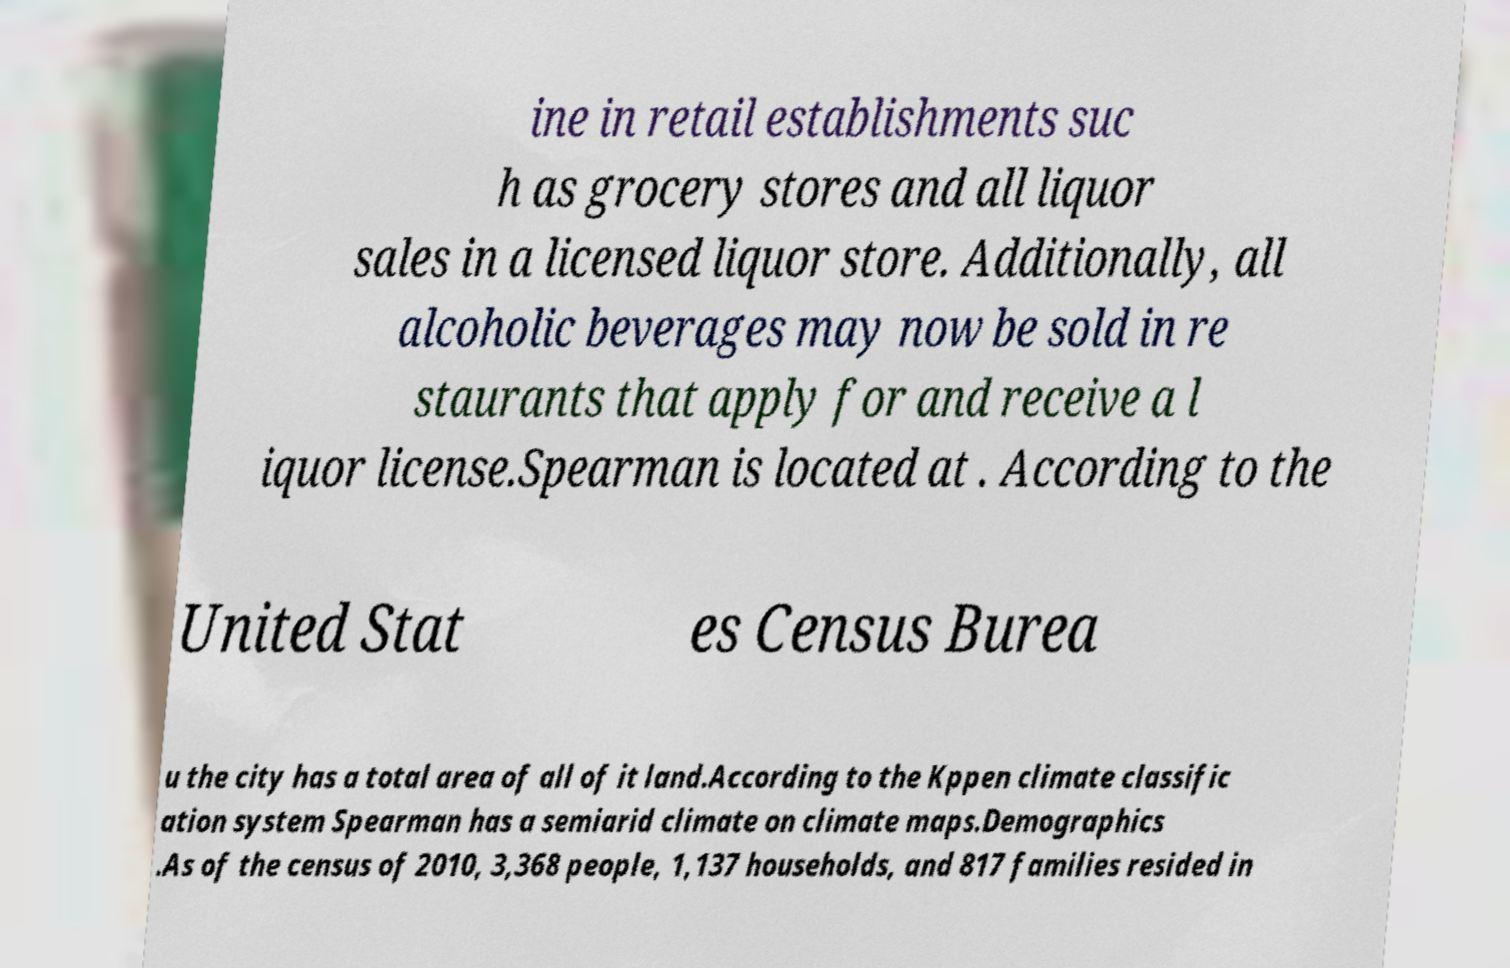Can you read and provide the text displayed in the image?This photo seems to have some interesting text. Can you extract and type it out for me? ine in retail establishments suc h as grocery stores and all liquor sales in a licensed liquor store. Additionally, all alcoholic beverages may now be sold in re staurants that apply for and receive a l iquor license.Spearman is located at . According to the United Stat es Census Burea u the city has a total area of all of it land.According to the Kppen climate classific ation system Spearman has a semiarid climate on climate maps.Demographics .As of the census of 2010, 3,368 people, 1,137 households, and 817 families resided in 